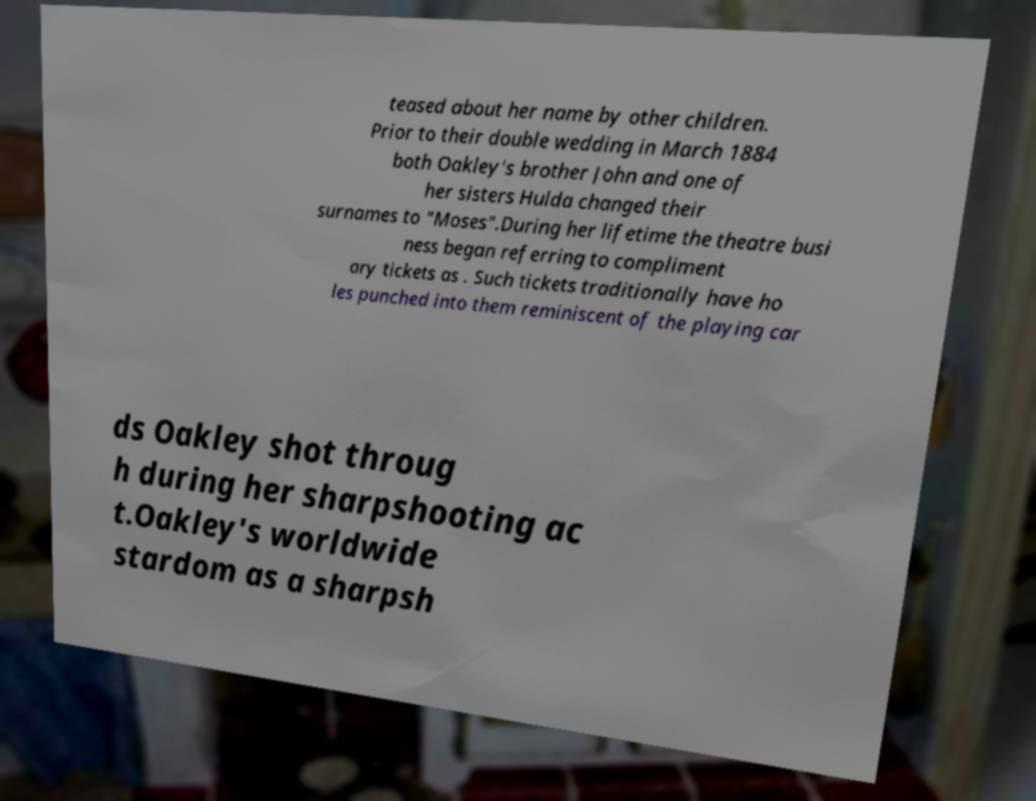Can you read and provide the text displayed in the image?This photo seems to have some interesting text. Can you extract and type it out for me? teased about her name by other children. Prior to their double wedding in March 1884 both Oakley's brother John and one of her sisters Hulda changed their surnames to "Moses".During her lifetime the theatre busi ness began referring to compliment ary tickets as . Such tickets traditionally have ho les punched into them reminiscent of the playing car ds Oakley shot throug h during her sharpshooting ac t.Oakley's worldwide stardom as a sharpsh 